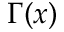Convert formula to latex. <formula><loc_0><loc_0><loc_500><loc_500>\Gamma ( x )</formula> 